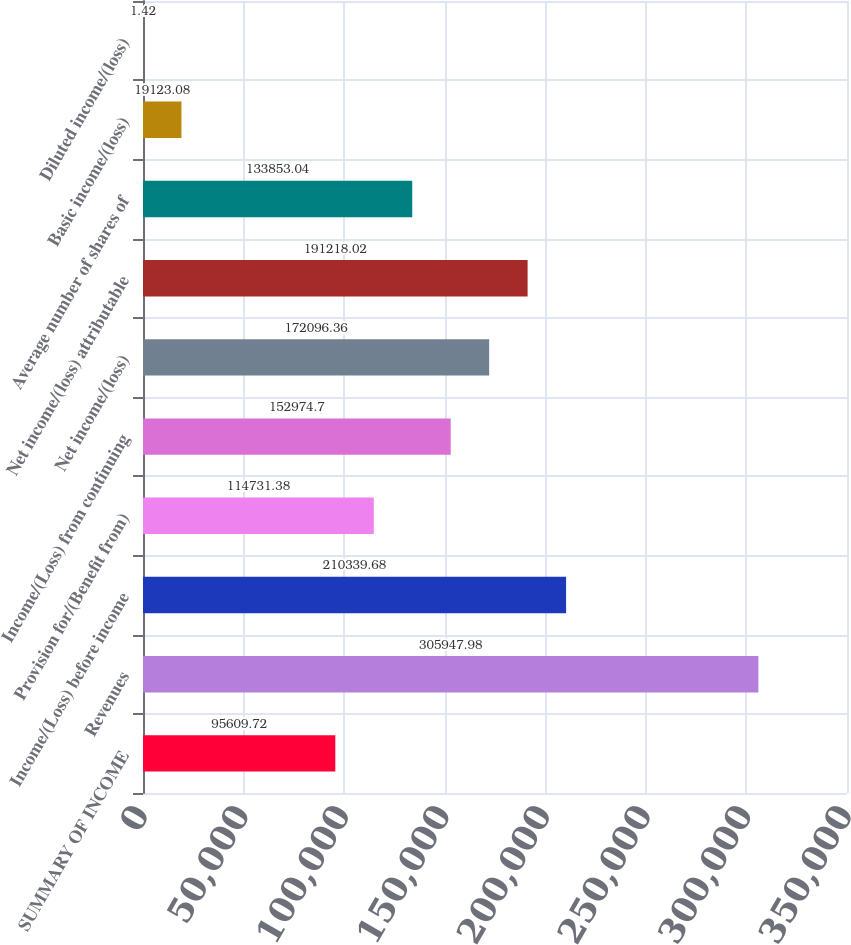Convert chart to OTSL. <chart><loc_0><loc_0><loc_500><loc_500><bar_chart><fcel>SUMMARY OF INCOME<fcel>Revenues<fcel>Income/(Loss) before income<fcel>Provision for/(Benefit from)<fcel>Income/(Loss) from continuing<fcel>Net income/(loss)<fcel>Net income/(loss) attributable<fcel>Average number of shares of<fcel>Basic income/(loss)<fcel>Diluted income/(loss)<nl><fcel>95609.7<fcel>305948<fcel>210340<fcel>114731<fcel>152975<fcel>172096<fcel>191218<fcel>133853<fcel>19123.1<fcel>1.42<nl></chart> 